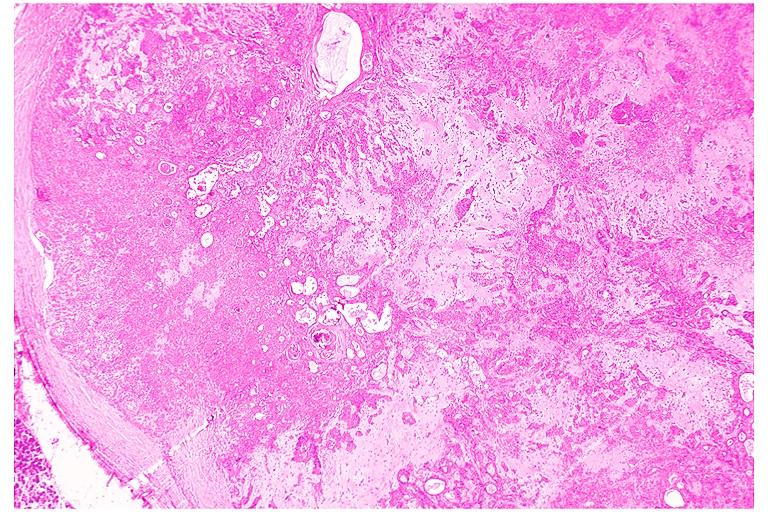what is present?
Answer the question using a single word or phrase. Oral 